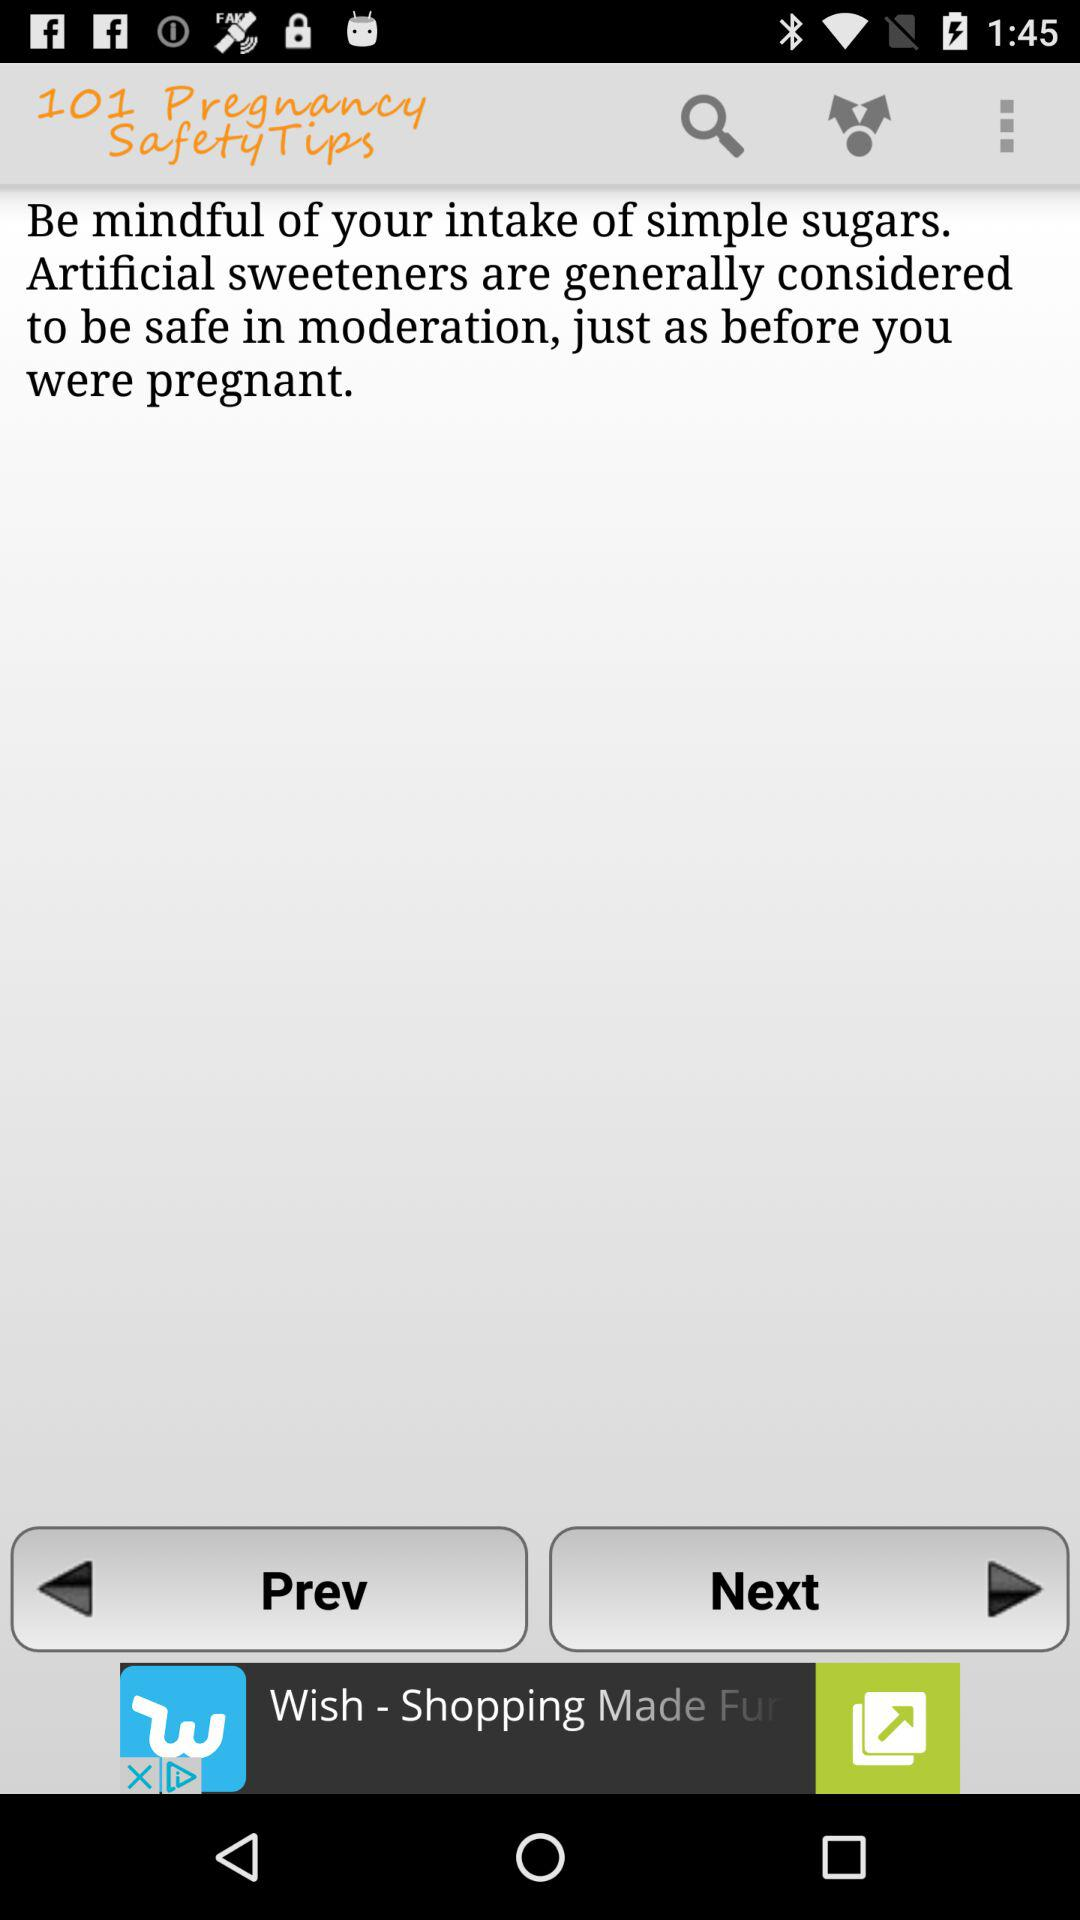What is the current pregnancy safety tip shown on the screen? The current pregnancy safety tip shown on the screen is "Be mindful of your intake of simple sugars. Artificial sweeteners are generally considered to be safe in moderation, just as before you were pregnant.". 